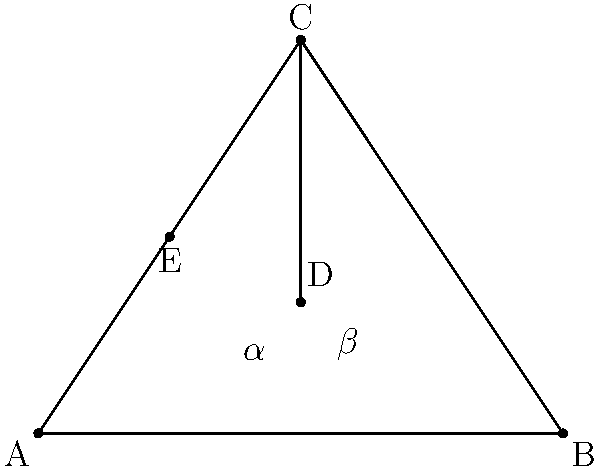In the design of a Commedia dell'Arte mask, the intersecting lines represent key facial features. Given that $\angle CAB = 60°$, $\angle CBA = 45°$, and line CD bisects $\angle ACB$, calculate the measure of angle $\alpha + \beta$. Let's approach this step-by-step:

1) In triangle ABC:
   $\angle CAB + \angle CBA + \angle ACB = 180°$ (sum of angles in a triangle)
   $60° + 45° + \angle ACB = 180°$
   $\angle ACB = 75°$

2) Since CD bisects $\angle ACB$, we know that:
   $\angle ACD = \angle BCD = \frac{1}{2} \angle ACB = \frac{75°}{2} = 37.5°$

3) In triangle ACD:
   $\angle CAD + \angle ACD + \angle ADE = 180°$ (sum of angles in a triangle)
   $60° + 37.5° + \angle ADE = 180°$
   $\angle ADE = 82.5°$

4) Similarly, in triangle BCD:
   $\angle CBD + \angle BCD + \angle BDE = 180°$
   $45° + 37.5° + \angle BDE = 180°$
   $\angle BDE = 97.5°$

5) Now, $\alpha + \beta = \angle ADE + \angle BDE = 82.5° + 97.5° = 180°$

Therefore, the measure of angle $\alpha + \beta$ is 180°.
Answer: $180°$ 